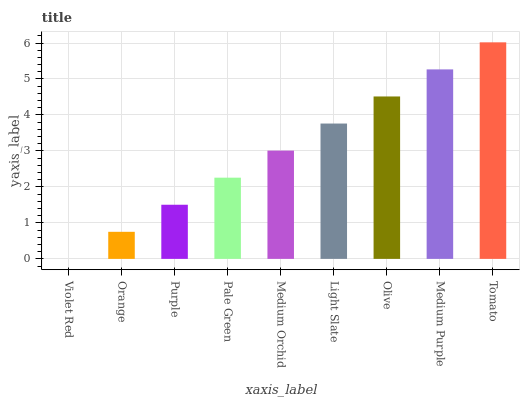Is Violet Red the minimum?
Answer yes or no. Yes. Is Tomato the maximum?
Answer yes or no. Yes. Is Orange the minimum?
Answer yes or no. No. Is Orange the maximum?
Answer yes or no. No. Is Orange greater than Violet Red?
Answer yes or no. Yes. Is Violet Red less than Orange?
Answer yes or no. Yes. Is Violet Red greater than Orange?
Answer yes or no. No. Is Orange less than Violet Red?
Answer yes or no. No. Is Medium Orchid the high median?
Answer yes or no. Yes. Is Medium Orchid the low median?
Answer yes or no. Yes. Is Orange the high median?
Answer yes or no. No. Is Purple the low median?
Answer yes or no. No. 